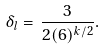Convert formula to latex. <formula><loc_0><loc_0><loc_500><loc_500>\delta _ { l } = \, \frac { 3 } { 2 ( 6 ) ^ { k / 2 } } .</formula> 